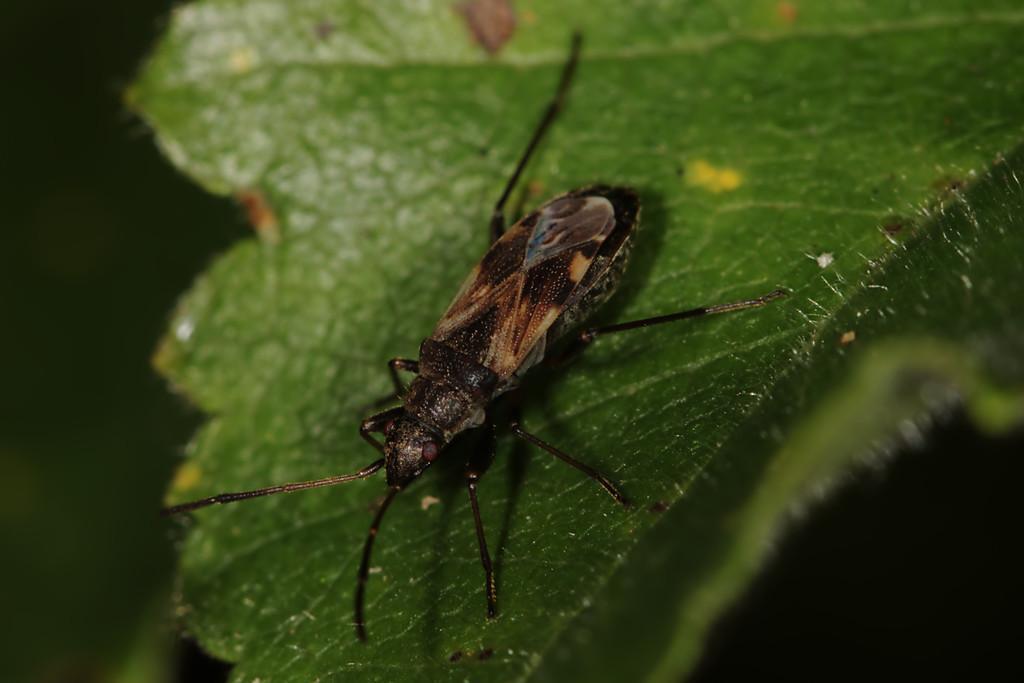Describe this image in one or two sentences. In this image there is an insect on the green leaf. 